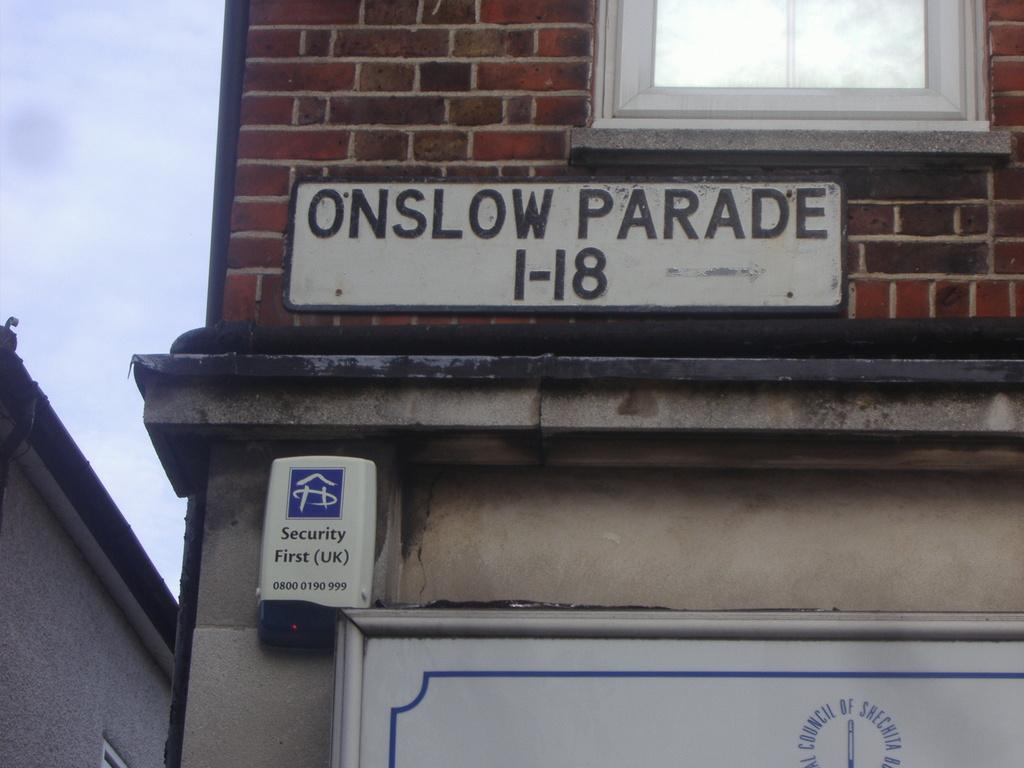What structure is located in the left corner of the image? There is a building in the left corner of the image. What feature can be seen on the building? The building has windows. What is visible in the foreground of the image? There is some text visible in the foreground of the image. What is visible at the top of the image? The sky is visible at the top of the image. How many police officers are standing in the shade in the image? There are no police officers or shaded areas present in the image. 